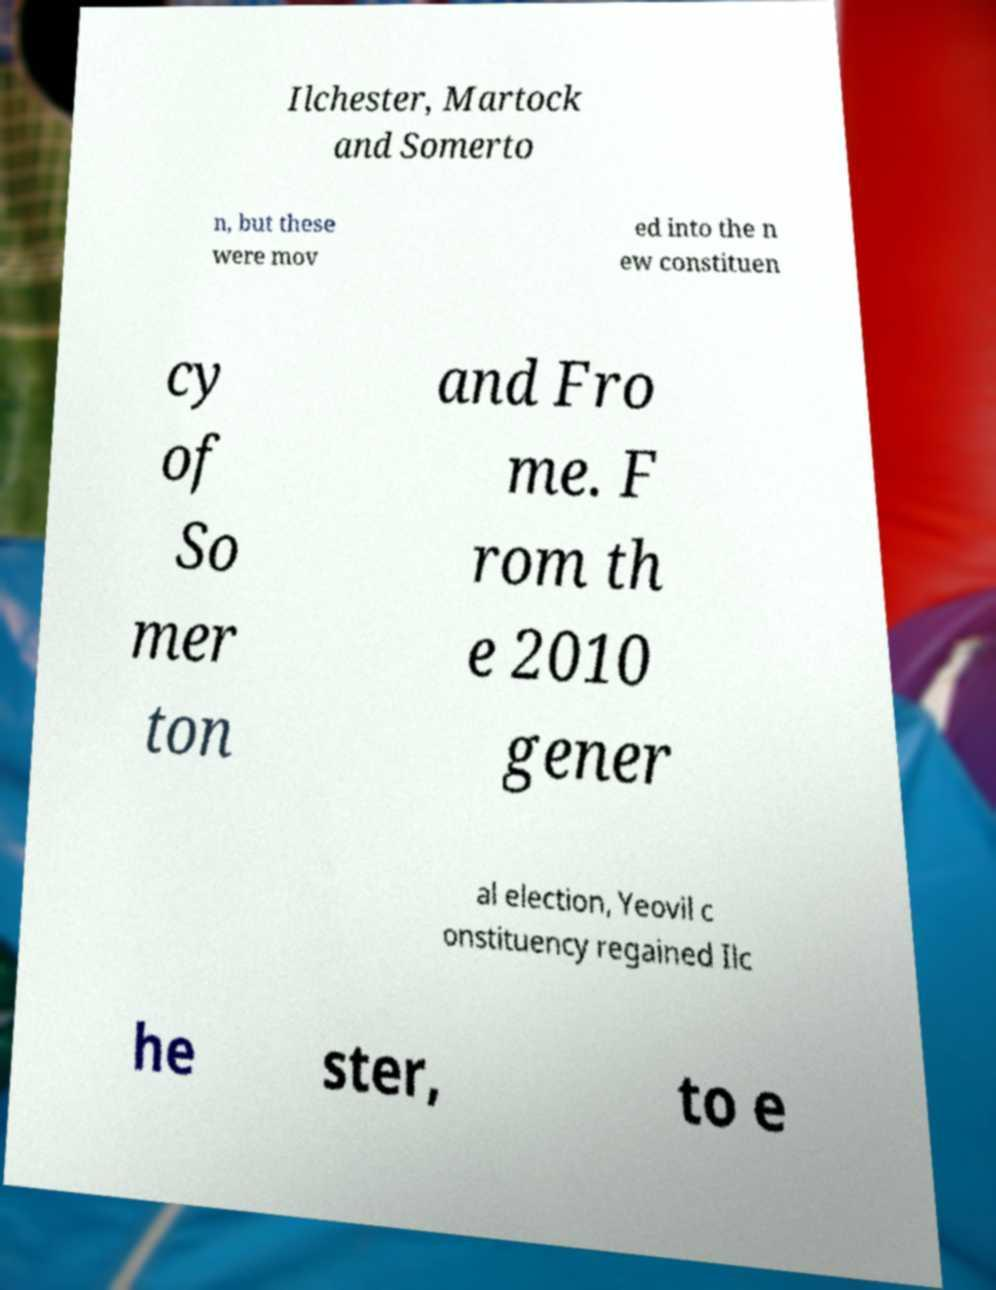Please read and relay the text visible in this image. What does it say? Ilchester, Martock and Somerto n, but these were mov ed into the n ew constituen cy of So mer ton and Fro me. F rom th e 2010 gener al election, Yeovil c onstituency regained Ilc he ster, to e 